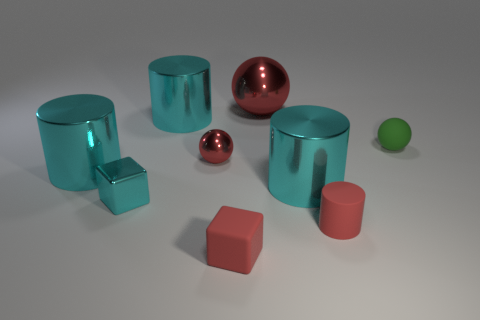What shape is the cyan object that is the same size as the red rubber block?
Your response must be concise. Cube. Is the number of green rubber spheres behind the green matte sphere the same as the number of small metal things that are right of the rubber cylinder?
Provide a succinct answer. Yes. Is there anything else that has the same shape as the small cyan object?
Provide a short and direct response. Yes. Does the cyan cylinder that is on the left side of the small cyan block have the same material as the small green object?
Keep it short and to the point. No. What material is the red cylinder that is the same size as the green sphere?
Your response must be concise. Rubber. What number of other things are made of the same material as the small cyan block?
Offer a terse response. 5. Do the green rubber object and the cyan shiny object on the left side of the cyan metallic cube have the same size?
Ensure brevity in your answer.  No. Are there fewer cyan cylinders that are to the left of the cyan block than big cylinders that are in front of the small rubber ball?
Your answer should be compact. Yes. There is a red sphere behind the matte sphere; what is its size?
Your answer should be very brief. Large. What number of balls are on the right side of the small red rubber cylinder and left of the small red rubber block?
Give a very brief answer. 0. 